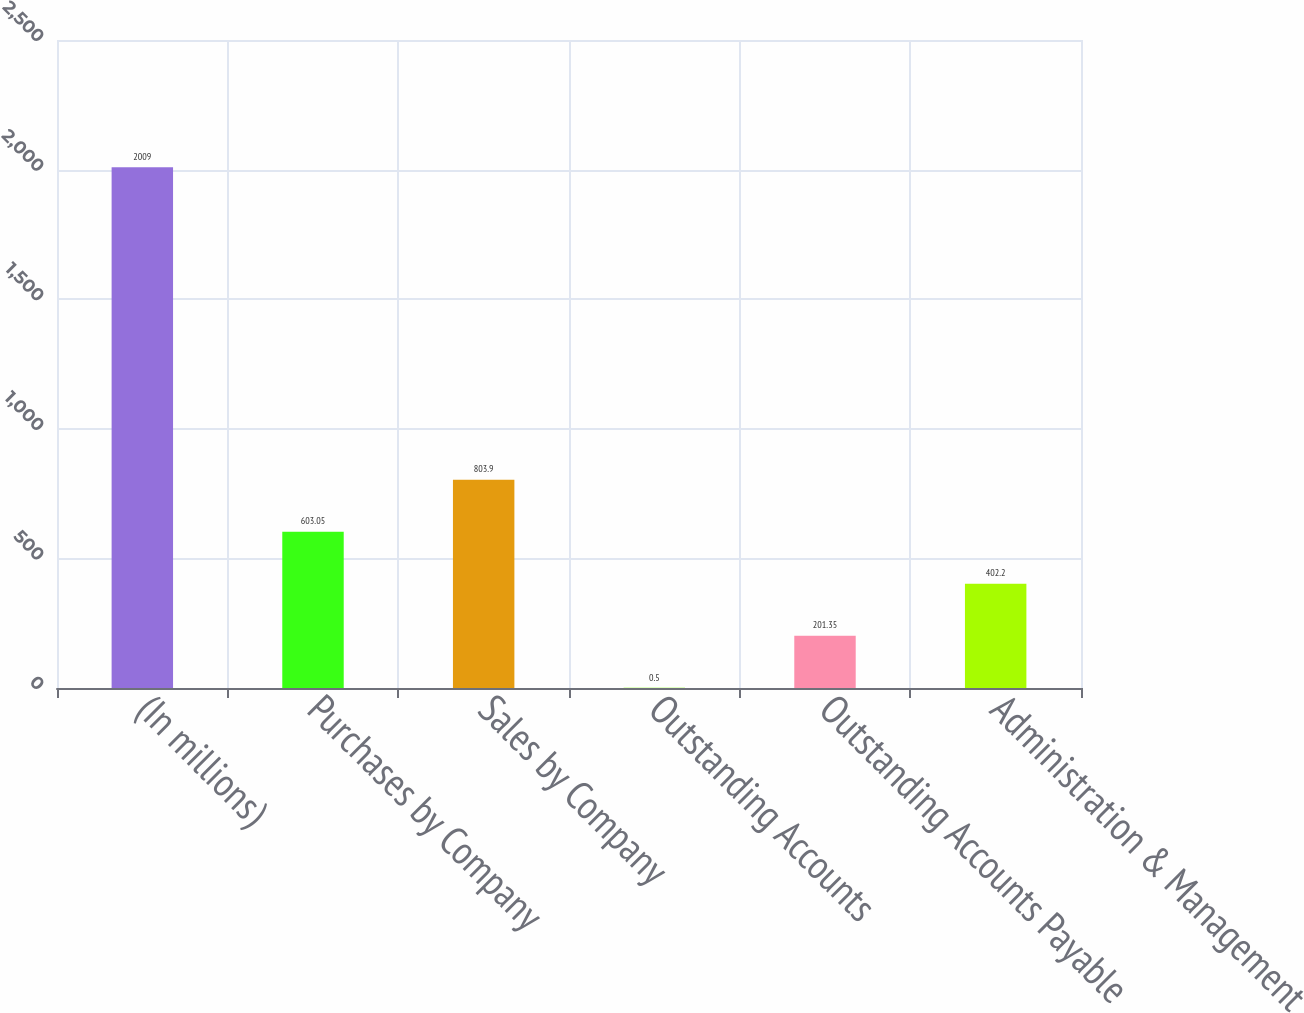<chart> <loc_0><loc_0><loc_500><loc_500><bar_chart><fcel>(In millions)<fcel>Purchases by Company<fcel>Sales by Company<fcel>Outstanding Accounts<fcel>Outstanding Accounts Payable<fcel>Administration & Management<nl><fcel>2009<fcel>603.05<fcel>803.9<fcel>0.5<fcel>201.35<fcel>402.2<nl></chart> 